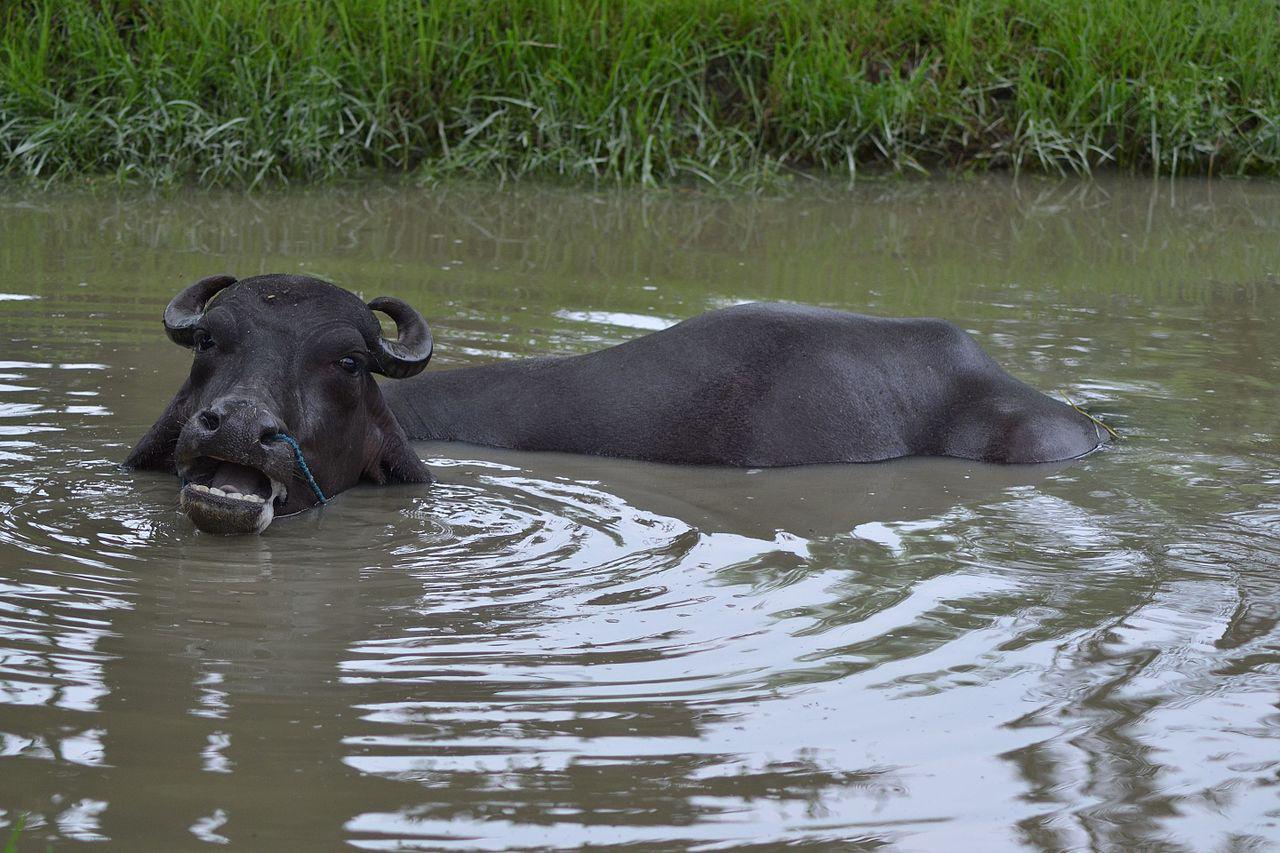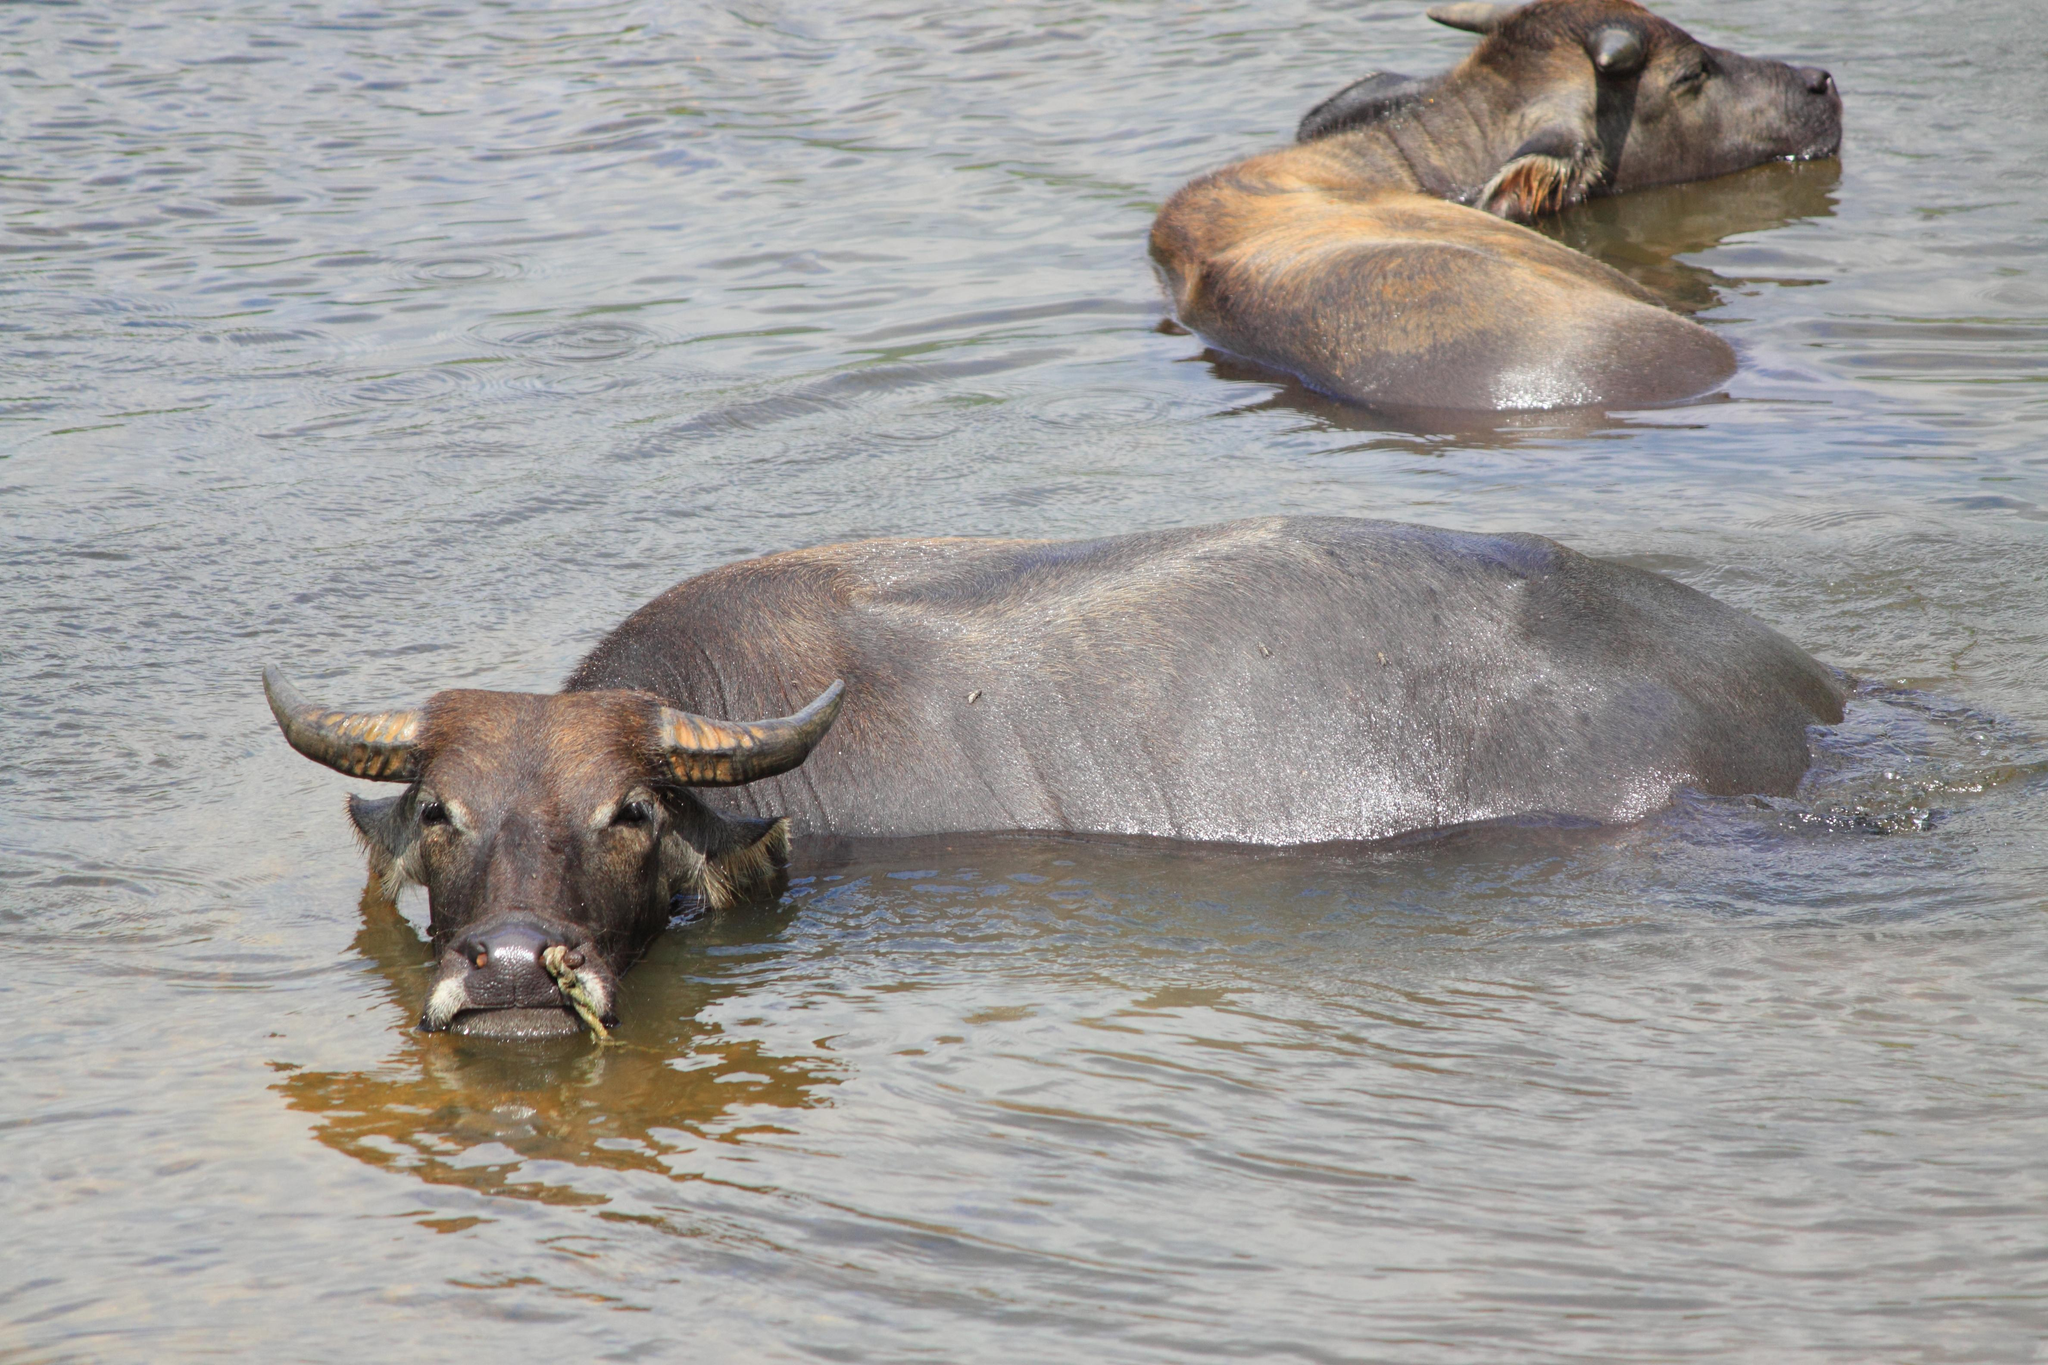The first image is the image on the left, the second image is the image on the right. For the images displayed, is the sentence "There are three animals in total." factually correct? Answer yes or no. Yes. 